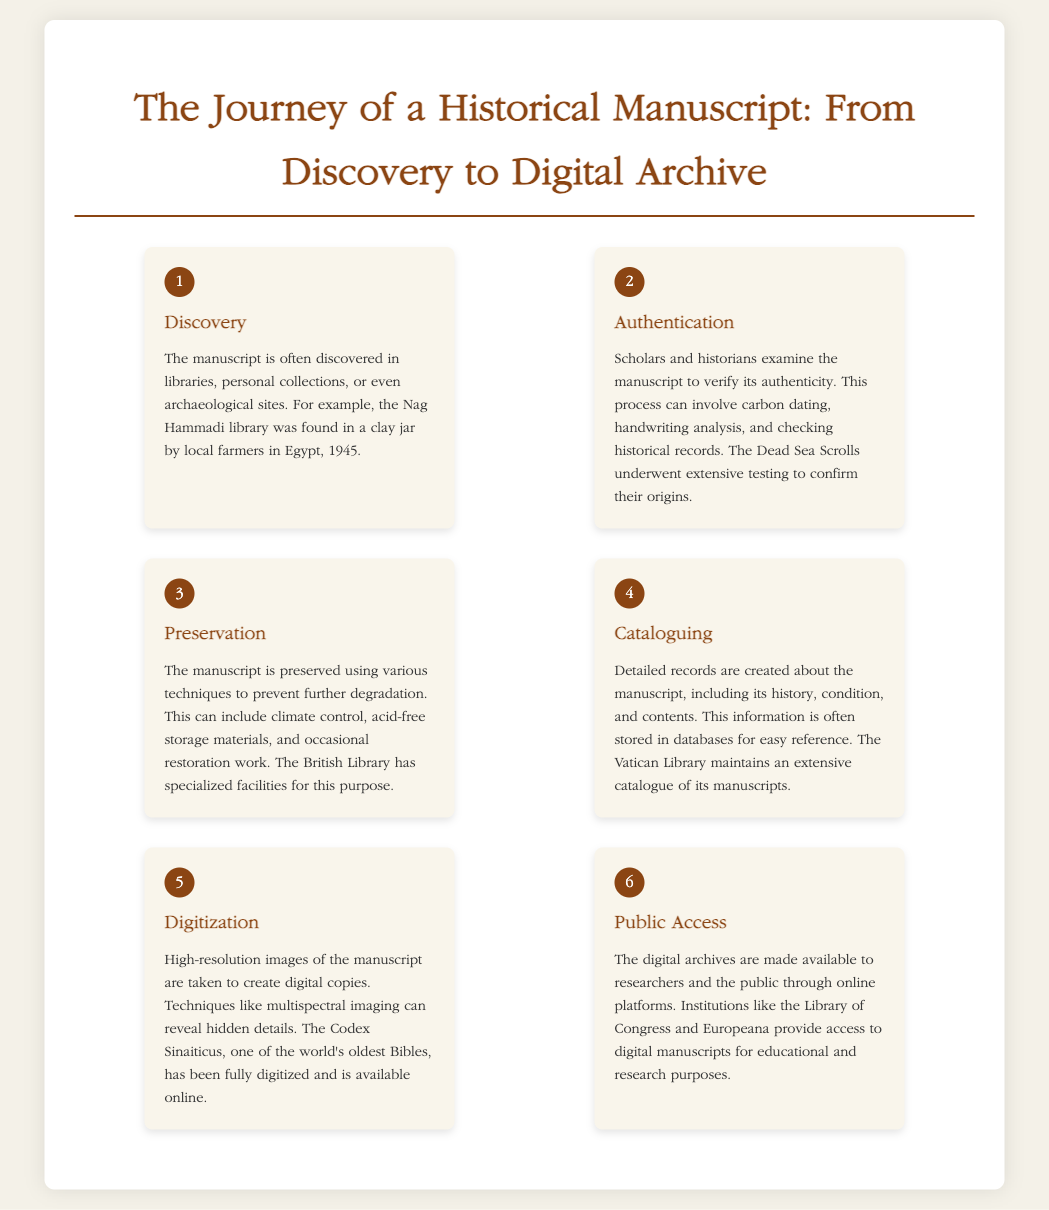What is the first step in the journey of a historical manuscript? The first step outlined in the infographic is "Discovery," where manuscripts are found in various locations such as libraries or archaeological sites.
Answer: Discovery What technique is used for manuscript preservation? The infographic mentions various techniques for preservation, including climate control, acid-free storage materials, and restoration work.
Answer: Climate control What significant library is mentioned in the context of extensive manuscript cataloguing? The document refers to the Vatican Library as an institution that maintains an extensive catalogue of its manuscripts.
Answer: Vatican Library How many steps are in the manuscript journey process? The infographic displays a total of six distinct steps in the journey of a historical manuscript.
Answer: Six Which manuscript is noted for being fully digitized and available online? The infographic specifically mentions the Codex Sinaiticus as one of the world's oldest Bibles that has been completely digitized.
Answer: Codex Sinaiticus What is the last step in the process of handling a historical manuscript? The final step in the journey of a manuscript, as described in the infographic, is "Public Access," where digital archives are made available online.
Answer: Public Access What year was the Nag Hammadi library discovered? The infographic states that the Nag Hammadi library was found in the year 1945.
Answer: 1945 What is the purpose of authentication in manuscript handling? The purpose of authentication is to verify the manuscript's authenticity through various scholarly methods like carbon dating and analysis.
Answer: Verify authenticity 